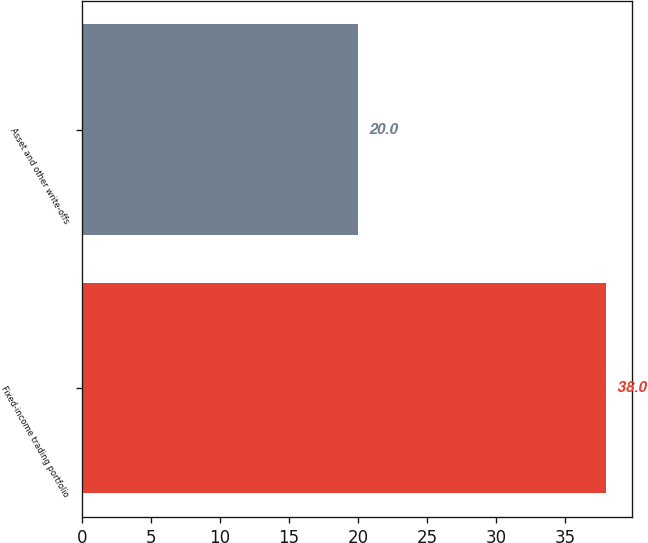<chart> <loc_0><loc_0><loc_500><loc_500><bar_chart><fcel>Fixed-income trading portfolio<fcel>Asset and other write-offs<nl><fcel>38<fcel>20<nl></chart> 